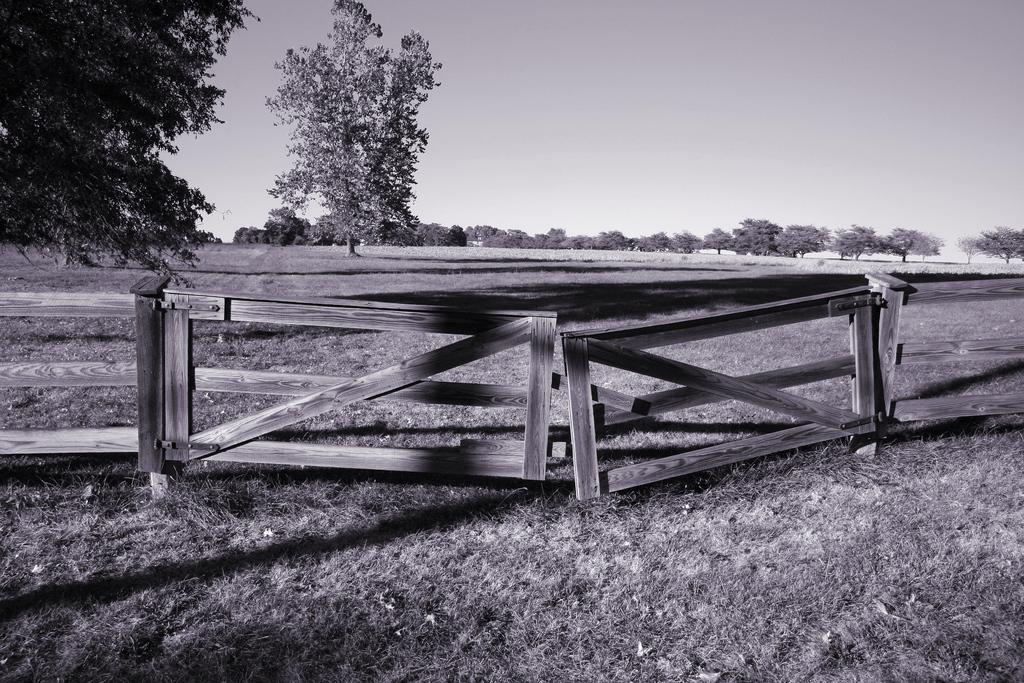Where was the picture taken? The picture was taken outside. What can be seen in the center of the image? There is a wooden fence in the center of the image. What type of vegetation is present in the image? There is grass in the image. What can be seen in the background of the image? The sky and trees are visible in the background of the image. What type of sand can be seen in the image? There is no sand present in the image; it features a wooden fence, grass, and trees. What reaction can be observed from the trees in the image? There is no reaction from the trees in the image, as trees do not have the ability to react. 